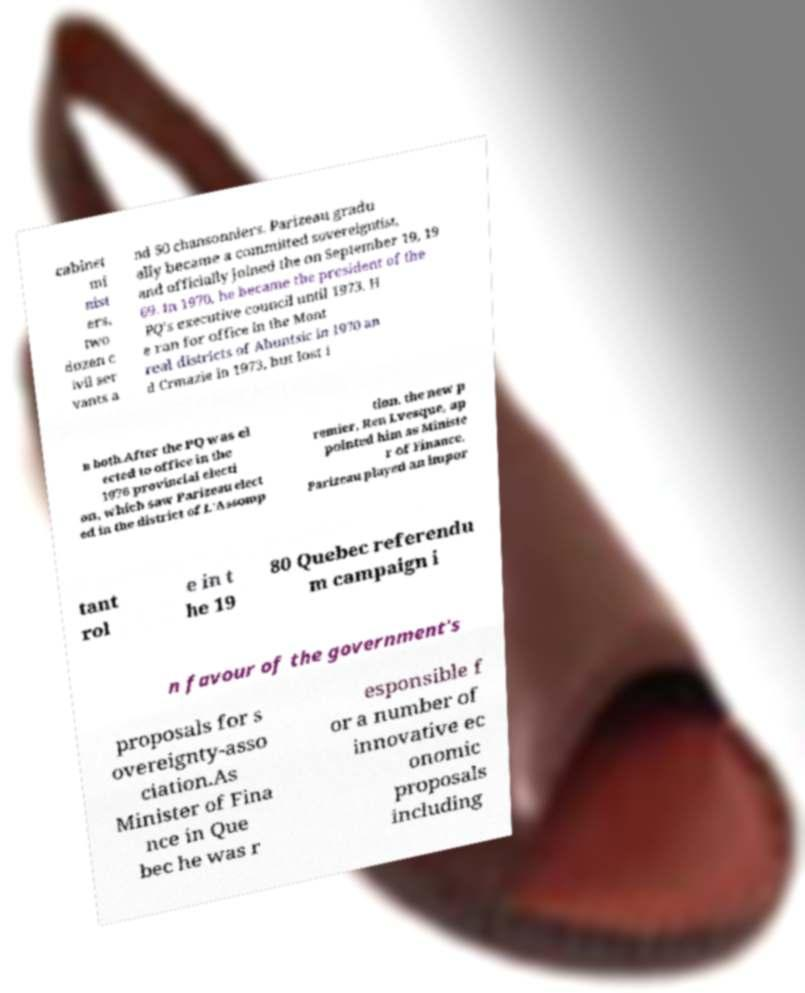What messages or text are displayed in this image? I need them in a readable, typed format. cabinet mi nist ers, two dozen c ivil ser vants a nd 50 chansonniers. Parizeau gradu ally became a committed sovereigntist, and officially joined the on September 19, 19 69. In 1970, he became the president of the PQ’s executive council until 1973. H e ran for office in the Mont real districts of Ahuntsic in 1970 an d Crmazie in 1973, but lost i n both.After the PQ was el ected to office in the 1976 provincial electi on, which saw Parizeau elect ed in the district of L'Assomp tion, the new p remier, Ren Lvesque, ap pointed him as Ministe r of Finance. Parizeau played an impor tant rol e in t he 19 80 Quebec referendu m campaign i n favour of the government's proposals for s overeignty-asso ciation.As Minister of Fina nce in Que bec he was r esponsible f or a number of innovative ec onomic proposals including 